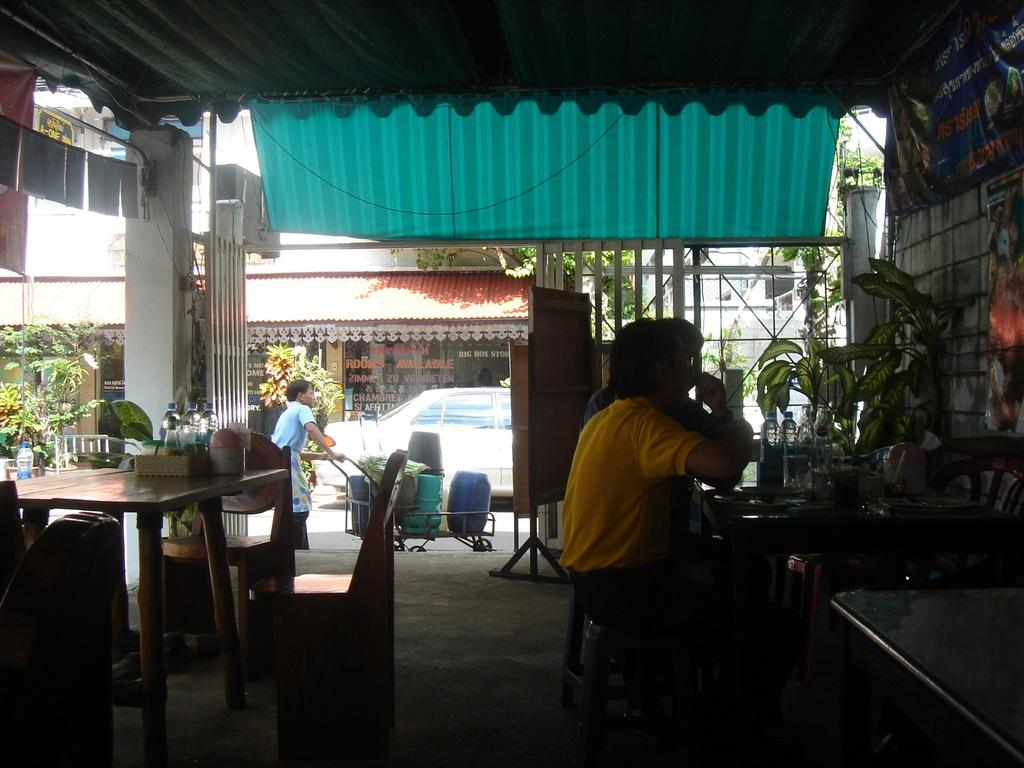How many people are sitting in the image? There are two persons sitting on chairs in the image. What are the people sitting in front of? The two persons are in front of a table. What is one person doing in the image? One person is walking and doing some work. What can be seen in the background of the image? There is a car and buildings visible in the image. What type of mitten is the person wearing while doing work in the image? There is no mitten visible in the image, and the person is not wearing any gloves or mittens. Is there any popcorn being served or eaten in the image? There is no popcorn present in the image. 